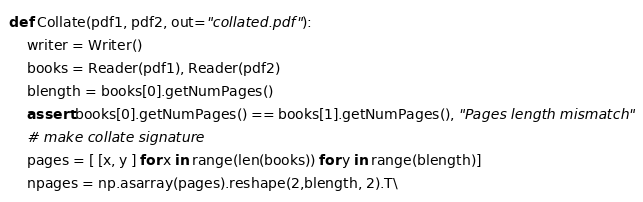<code> <loc_0><loc_0><loc_500><loc_500><_Python_>
def Collate(pdf1, pdf2, out="collated.pdf"):
    writer = Writer()
    books = Reader(pdf1), Reader(pdf2)
    blength = books[0].getNumPages()
    assert books[0].getNumPages() == books[1].getNumPages(), "Pages length mismatch"
    # make collate signature
    pages = [ [x, y ] for x in range(len(books)) for y in range(blength)]
    npages = np.asarray(pages).reshape(2,blength, 2).T\</code> 